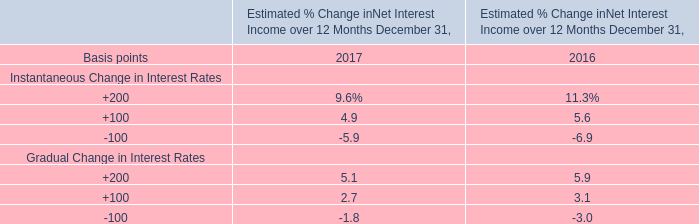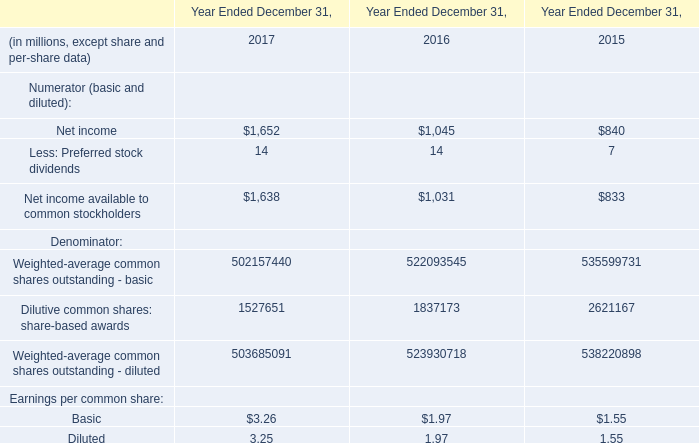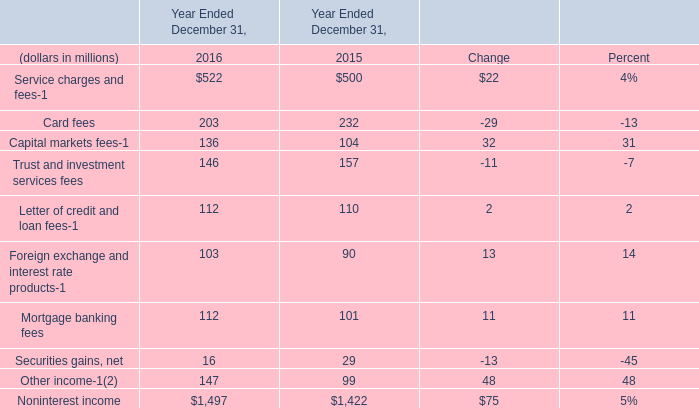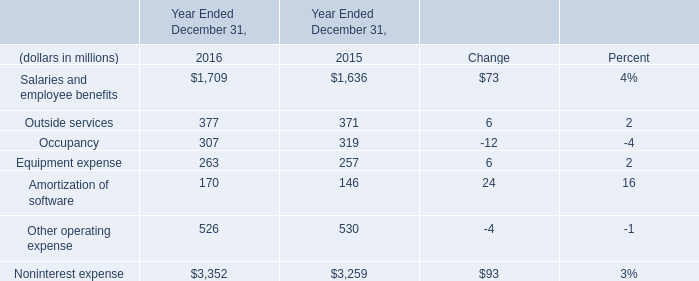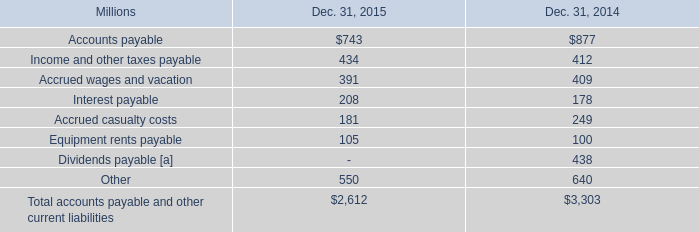If Salaries and employee benefits develops with the same growth rate in 2016, what will it reach in 2017? (in million) 
Computations: (1709 + ((1709 * (1709 - 1636)) / 1636))
Answer: 1785.25733. 